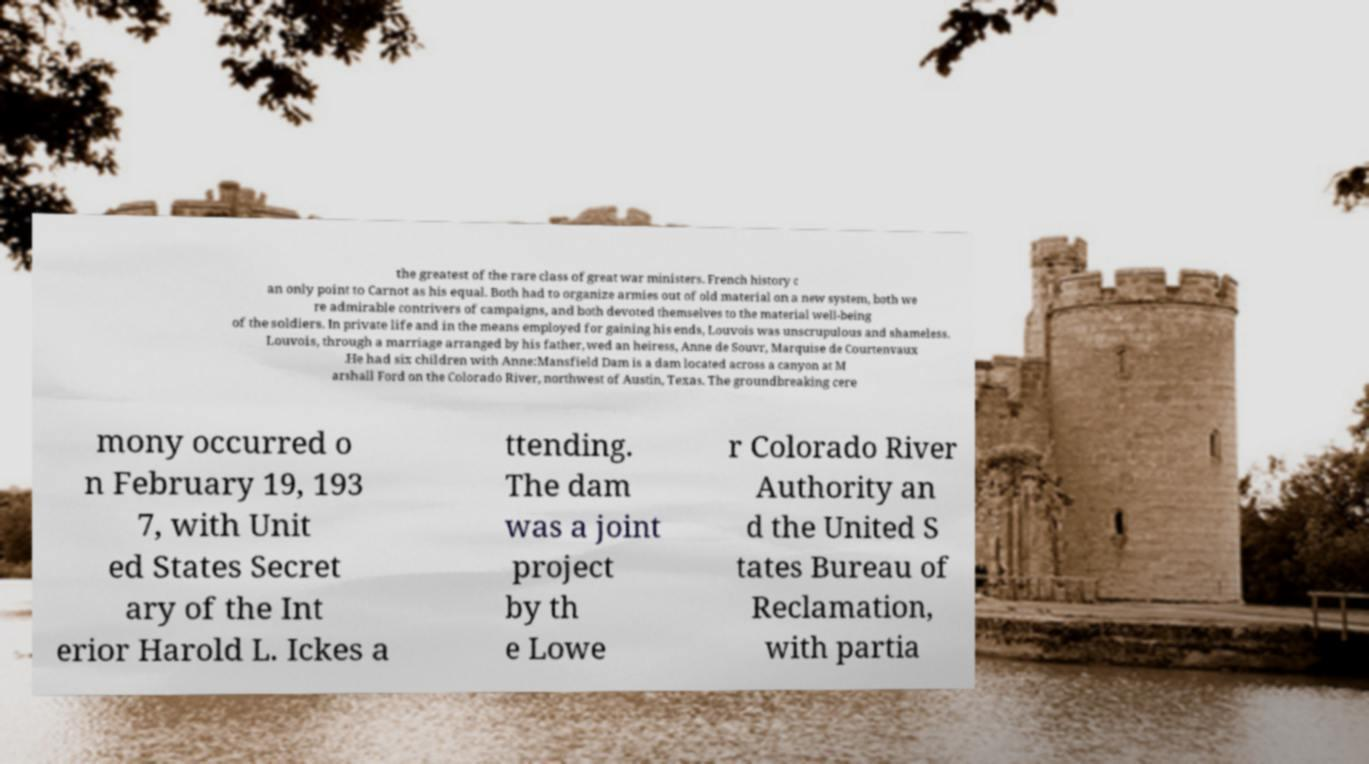Please read and relay the text visible in this image. What does it say? the greatest of the rare class of great war ministers. French history c an only point to Carnot as his equal. Both had to organize armies out of old material on a new system, both we re admirable contrivers of campaigns, and both devoted themselves to the material well-being of the soldiers. In private life and in the means employed for gaining his ends, Louvois was unscrupulous and shameless. Louvois, through a marriage arranged by his father, wed an heiress, Anne de Souvr, Marquise de Courtenvaux .He had six children with Anne:Mansfield Dam is a dam located across a canyon at M arshall Ford on the Colorado River, northwest of Austin, Texas. The groundbreaking cere mony occurred o n February 19, 193 7, with Unit ed States Secret ary of the Int erior Harold L. Ickes a ttending. The dam was a joint project by th e Lowe r Colorado River Authority an d the United S tates Bureau of Reclamation, with partia 